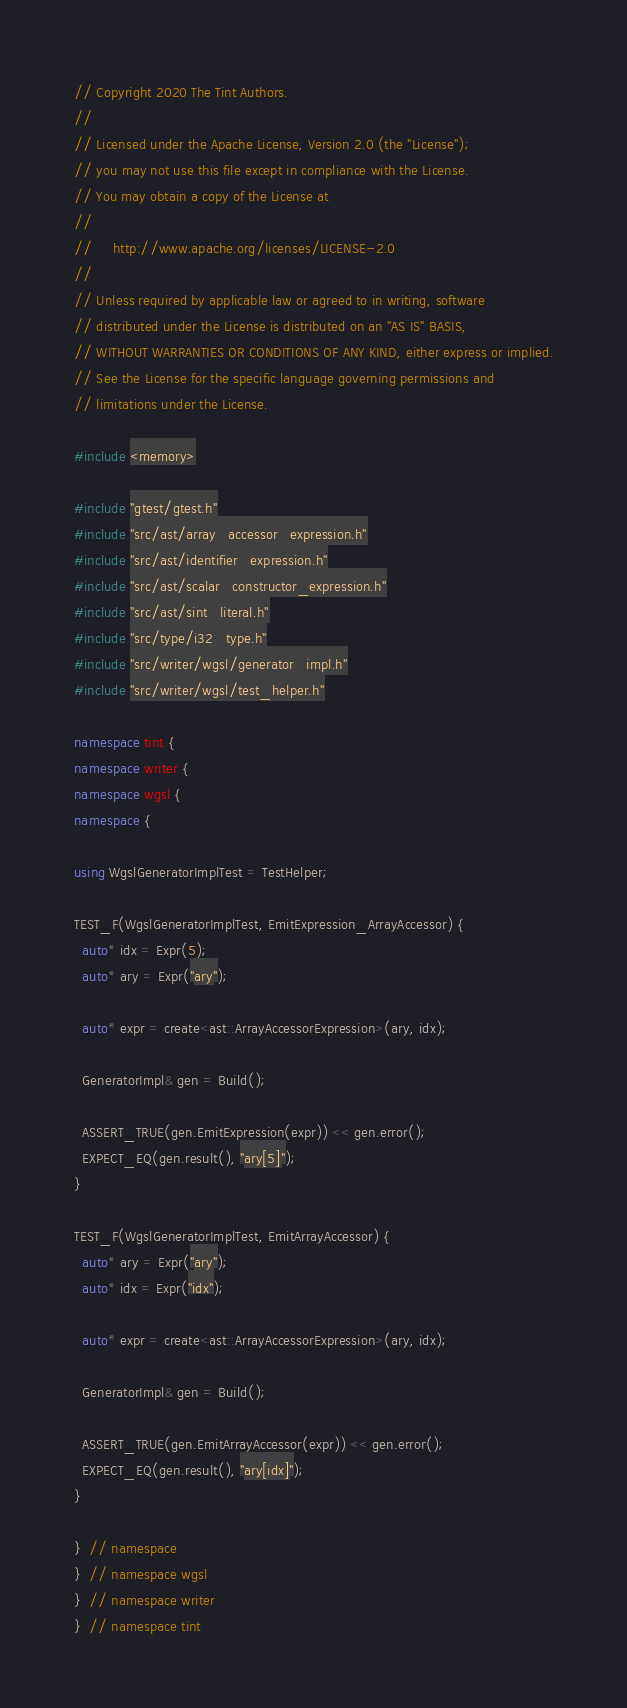<code> <loc_0><loc_0><loc_500><loc_500><_C++_>// Copyright 2020 The Tint Authors.
//
// Licensed under the Apache License, Version 2.0 (the "License");
// you may not use this file except in compliance with the License.
// You may obtain a copy of the License at
//
//     http://www.apache.org/licenses/LICENSE-2.0
//
// Unless required by applicable law or agreed to in writing, software
// distributed under the License is distributed on an "AS IS" BASIS,
// WITHOUT WARRANTIES OR CONDITIONS OF ANY KIND, either express or implied.
// See the License for the specific language governing permissions and
// limitations under the License.

#include <memory>

#include "gtest/gtest.h"
#include "src/ast/array_accessor_expression.h"
#include "src/ast/identifier_expression.h"
#include "src/ast/scalar_constructor_expression.h"
#include "src/ast/sint_literal.h"
#include "src/type/i32_type.h"
#include "src/writer/wgsl/generator_impl.h"
#include "src/writer/wgsl/test_helper.h"

namespace tint {
namespace writer {
namespace wgsl {
namespace {

using WgslGeneratorImplTest = TestHelper;

TEST_F(WgslGeneratorImplTest, EmitExpression_ArrayAccessor) {
  auto* idx = Expr(5);
  auto* ary = Expr("ary");

  auto* expr = create<ast::ArrayAccessorExpression>(ary, idx);

  GeneratorImpl& gen = Build();

  ASSERT_TRUE(gen.EmitExpression(expr)) << gen.error();
  EXPECT_EQ(gen.result(), "ary[5]");
}

TEST_F(WgslGeneratorImplTest, EmitArrayAccessor) {
  auto* ary = Expr("ary");
  auto* idx = Expr("idx");

  auto* expr = create<ast::ArrayAccessorExpression>(ary, idx);

  GeneratorImpl& gen = Build();

  ASSERT_TRUE(gen.EmitArrayAccessor(expr)) << gen.error();
  EXPECT_EQ(gen.result(), "ary[idx]");
}

}  // namespace
}  // namespace wgsl
}  // namespace writer
}  // namespace tint
</code> 